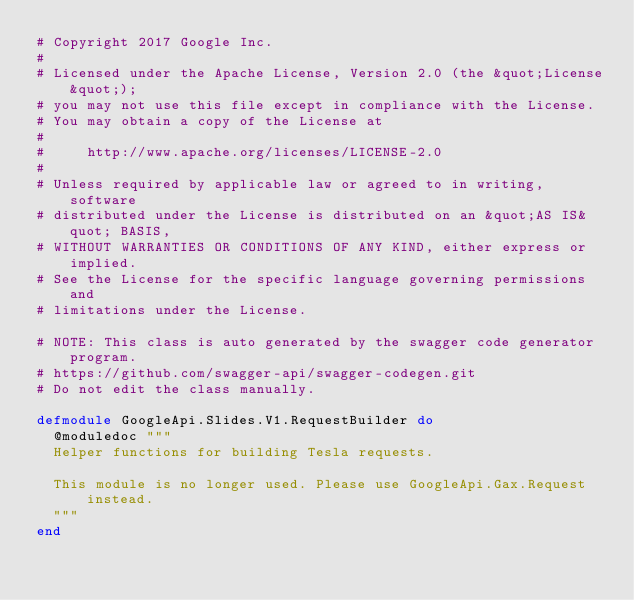<code> <loc_0><loc_0><loc_500><loc_500><_Elixir_># Copyright 2017 Google Inc.
#
# Licensed under the Apache License, Version 2.0 (the &quot;License&quot;);
# you may not use this file except in compliance with the License.
# You may obtain a copy of the License at
#
#     http://www.apache.org/licenses/LICENSE-2.0
#
# Unless required by applicable law or agreed to in writing, software
# distributed under the License is distributed on an &quot;AS IS&quot; BASIS,
# WITHOUT WARRANTIES OR CONDITIONS OF ANY KIND, either express or implied.
# See the License for the specific language governing permissions and
# limitations under the License.

# NOTE: This class is auto generated by the swagger code generator program.
# https://github.com/swagger-api/swagger-codegen.git
# Do not edit the class manually.

defmodule GoogleApi.Slides.V1.RequestBuilder do
  @moduledoc """
  Helper functions for building Tesla requests.

  This module is no longer used. Please use GoogleApi.Gax.Request instead.
  """
end
</code> 